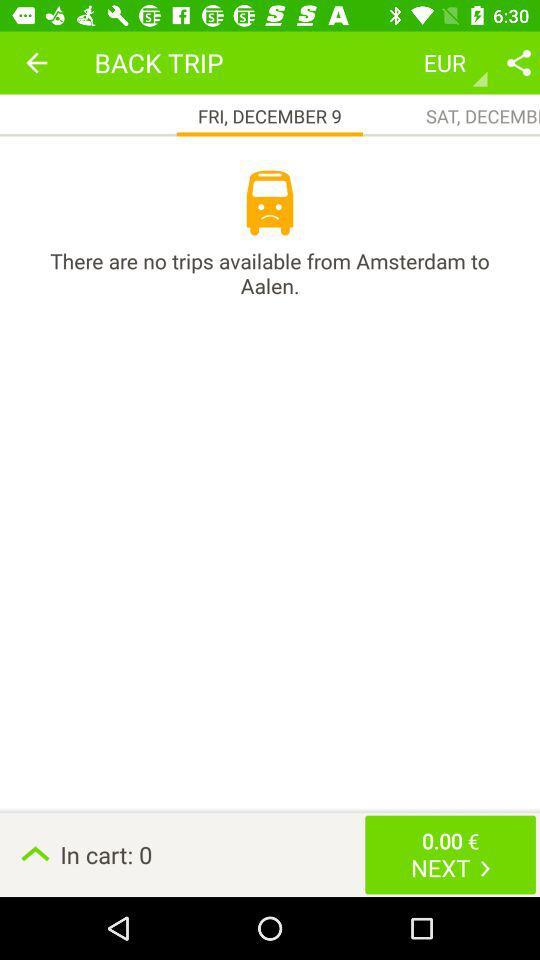What's the selected date? The selected date is Friday, December 9. 